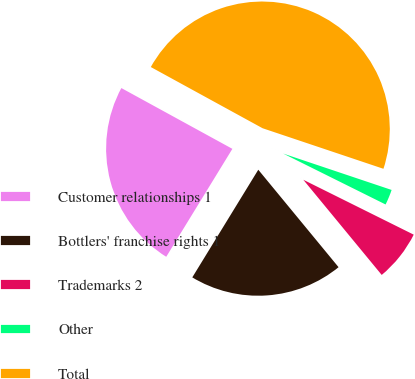<chart> <loc_0><loc_0><loc_500><loc_500><pie_chart><fcel>Customer relationships 1<fcel>Bottlers' franchise rights 1<fcel>Trademarks 2<fcel>Other<fcel>Total<nl><fcel>24.22%<fcel>19.72%<fcel>6.69%<fcel>2.19%<fcel>47.18%<nl></chart> 